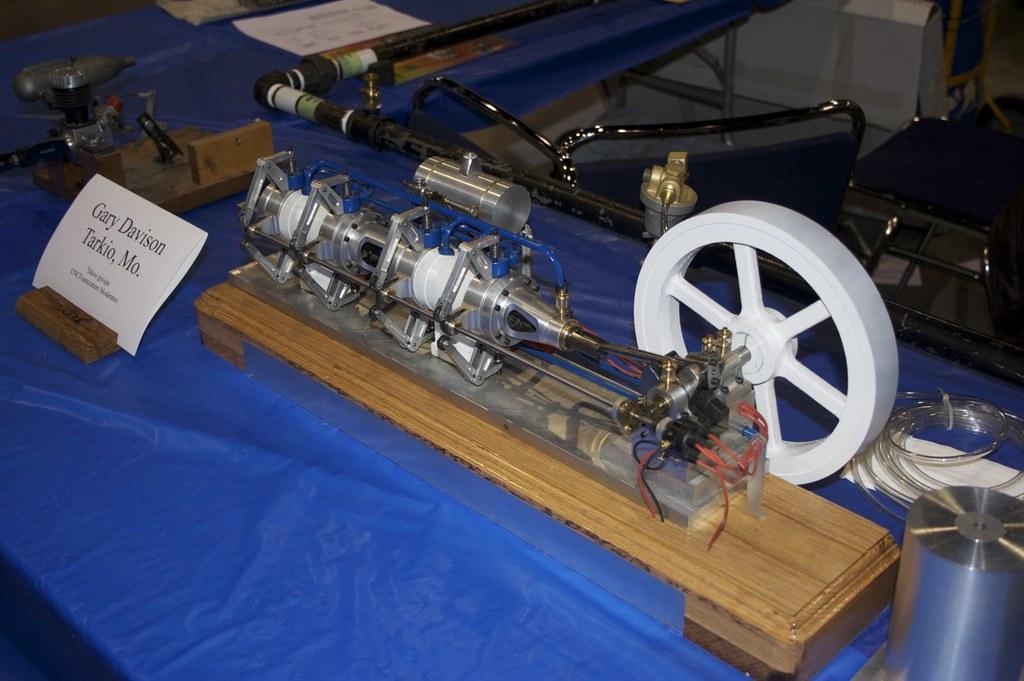Could you give a brief overview of what you see in this image? In this image I can see few tables and on it I can see blue colour table cloths, aboard, few equipment and on the board I can see something is written. On the top right side of this image I can see few chairs. 